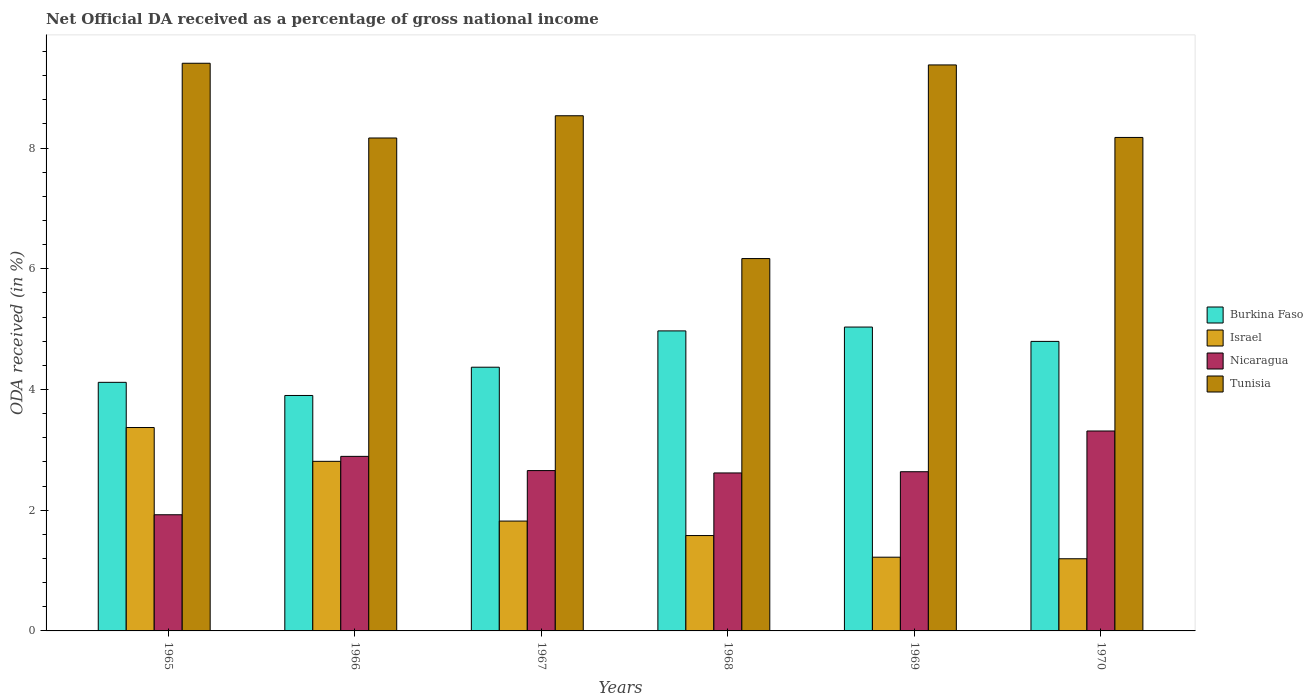How many groups of bars are there?
Your answer should be compact. 6. Are the number of bars on each tick of the X-axis equal?
Ensure brevity in your answer.  Yes. How many bars are there on the 2nd tick from the right?
Make the answer very short. 4. What is the label of the 3rd group of bars from the left?
Offer a very short reply. 1967. In how many cases, is the number of bars for a given year not equal to the number of legend labels?
Your response must be concise. 0. What is the net official DA received in Tunisia in 1970?
Provide a succinct answer. 8.18. Across all years, what is the maximum net official DA received in Burkina Faso?
Provide a succinct answer. 5.03. Across all years, what is the minimum net official DA received in Nicaragua?
Offer a terse response. 1.92. In which year was the net official DA received in Nicaragua minimum?
Provide a short and direct response. 1965. What is the total net official DA received in Nicaragua in the graph?
Offer a very short reply. 16.04. What is the difference between the net official DA received in Nicaragua in 1967 and that in 1969?
Offer a terse response. 0.02. What is the difference between the net official DA received in Burkina Faso in 1968 and the net official DA received in Israel in 1967?
Give a very brief answer. 3.15. What is the average net official DA received in Burkina Faso per year?
Offer a terse response. 4.53. In the year 1970, what is the difference between the net official DA received in Tunisia and net official DA received in Nicaragua?
Offer a very short reply. 4.86. What is the ratio of the net official DA received in Tunisia in 1965 to that in 1967?
Provide a succinct answer. 1.1. Is the net official DA received in Nicaragua in 1966 less than that in 1969?
Make the answer very short. No. What is the difference between the highest and the second highest net official DA received in Nicaragua?
Ensure brevity in your answer.  0.42. What is the difference between the highest and the lowest net official DA received in Nicaragua?
Keep it short and to the point. 1.39. In how many years, is the net official DA received in Burkina Faso greater than the average net official DA received in Burkina Faso taken over all years?
Your answer should be compact. 3. Is the sum of the net official DA received in Nicaragua in 1966 and 1968 greater than the maximum net official DA received in Israel across all years?
Make the answer very short. Yes. Is it the case that in every year, the sum of the net official DA received in Tunisia and net official DA received in Israel is greater than the sum of net official DA received in Burkina Faso and net official DA received in Nicaragua?
Provide a short and direct response. Yes. What does the 1st bar from the left in 1969 represents?
Your response must be concise. Burkina Faso. What does the 2nd bar from the right in 1965 represents?
Ensure brevity in your answer.  Nicaragua. How many years are there in the graph?
Make the answer very short. 6. What is the difference between two consecutive major ticks on the Y-axis?
Give a very brief answer. 2. Are the values on the major ticks of Y-axis written in scientific E-notation?
Your answer should be very brief. No. Does the graph contain grids?
Make the answer very short. No. Where does the legend appear in the graph?
Your answer should be compact. Center right. How many legend labels are there?
Your answer should be compact. 4. What is the title of the graph?
Provide a succinct answer. Net Official DA received as a percentage of gross national income. What is the label or title of the X-axis?
Make the answer very short. Years. What is the label or title of the Y-axis?
Your answer should be very brief. ODA received (in %). What is the ODA received (in %) of Burkina Faso in 1965?
Your response must be concise. 4.12. What is the ODA received (in %) of Israel in 1965?
Ensure brevity in your answer.  3.37. What is the ODA received (in %) of Nicaragua in 1965?
Provide a succinct answer. 1.92. What is the ODA received (in %) of Tunisia in 1965?
Provide a succinct answer. 9.41. What is the ODA received (in %) in Burkina Faso in 1966?
Keep it short and to the point. 3.9. What is the ODA received (in %) of Israel in 1966?
Make the answer very short. 2.81. What is the ODA received (in %) in Nicaragua in 1966?
Your answer should be compact. 2.89. What is the ODA received (in %) of Tunisia in 1966?
Your answer should be very brief. 8.17. What is the ODA received (in %) of Burkina Faso in 1967?
Provide a short and direct response. 4.37. What is the ODA received (in %) of Israel in 1967?
Provide a succinct answer. 1.82. What is the ODA received (in %) of Nicaragua in 1967?
Provide a short and direct response. 2.66. What is the ODA received (in %) of Tunisia in 1967?
Provide a short and direct response. 8.54. What is the ODA received (in %) of Burkina Faso in 1968?
Your response must be concise. 4.97. What is the ODA received (in %) in Israel in 1968?
Your response must be concise. 1.58. What is the ODA received (in %) of Nicaragua in 1968?
Your response must be concise. 2.62. What is the ODA received (in %) in Tunisia in 1968?
Your answer should be very brief. 6.17. What is the ODA received (in %) of Burkina Faso in 1969?
Keep it short and to the point. 5.03. What is the ODA received (in %) of Israel in 1969?
Ensure brevity in your answer.  1.22. What is the ODA received (in %) in Nicaragua in 1969?
Provide a succinct answer. 2.64. What is the ODA received (in %) in Tunisia in 1969?
Offer a terse response. 9.38. What is the ODA received (in %) of Burkina Faso in 1970?
Your answer should be compact. 4.8. What is the ODA received (in %) in Israel in 1970?
Keep it short and to the point. 1.2. What is the ODA received (in %) of Nicaragua in 1970?
Give a very brief answer. 3.31. What is the ODA received (in %) of Tunisia in 1970?
Your response must be concise. 8.18. Across all years, what is the maximum ODA received (in %) of Burkina Faso?
Provide a succinct answer. 5.03. Across all years, what is the maximum ODA received (in %) in Israel?
Offer a very short reply. 3.37. Across all years, what is the maximum ODA received (in %) in Nicaragua?
Your answer should be very brief. 3.31. Across all years, what is the maximum ODA received (in %) in Tunisia?
Provide a succinct answer. 9.41. Across all years, what is the minimum ODA received (in %) of Burkina Faso?
Your response must be concise. 3.9. Across all years, what is the minimum ODA received (in %) of Israel?
Offer a very short reply. 1.2. Across all years, what is the minimum ODA received (in %) of Nicaragua?
Make the answer very short. 1.92. Across all years, what is the minimum ODA received (in %) of Tunisia?
Your answer should be very brief. 6.17. What is the total ODA received (in %) in Burkina Faso in the graph?
Make the answer very short. 27.19. What is the total ODA received (in %) of Israel in the graph?
Make the answer very short. 12. What is the total ODA received (in %) in Nicaragua in the graph?
Provide a succinct answer. 16.04. What is the total ODA received (in %) in Tunisia in the graph?
Your answer should be compact. 49.83. What is the difference between the ODA received (in %) in Burkina Faso in 1965 and that in 1966?
Keep it short and to the point. 0.22. What is the difference between the ODA received (in %) of Israel in 1965 and that in 1966?
Ensure brevity in your answer.  0.56. What is the difference between the ODA received (in %) in Nicaragua in 1965 and that in 1966?
Keep it short and to the point. -0.97. What is the difference between the ODA received (in %) of Tunisia in 1965 and that in 1966?
Make the answer very short. 1.24. What is the difference between the ODA received (in %) in Burkina Faso in 1965 and that in 1967?
Your answer should be very brief. -0.25. What is the difference between the ODA received (in %) in Israel in 1965 and that in 1967?
Your answer should be compact. 1.55. What is the difference between the ODA received (in %) in Nicaragua in 1965 and that in 1967?
Make the answer very short. -0.73. What is the difference between the ODA received (in %) of Tunisia in 1965 and that in 1967?
Keep it short and to the point. 0.87. What is the difference between the ODA received (in %) in Burkina Faso in 1965 and that in 1968?
Make the answer very short. -0.85. What is the difference between the ODA received (in %) in Israel in 1965 and that in 1968?
Offer a terse response. 1.79. What is the difference between the ODA received (in %) in Nicaragua in 1965 and that in 1968?
Offer a terse response. -0.69. What is the difference between the ODA received (in %) in Tunisia in 1965 and that in 1968?
Keep it short and to the point. 3.24. What is the difference between the ODA received (in %) of Burkina Faso in 1965 and that in 1969?
Offer a very short reply. -0.92. What is the difference between the ODA received (in %) in Israel in 1965 and that in 1969?
Make the answer very short. 2.15. What is the difference between the ODA received (in %) of Nicaragua in 1965 and that in 1969?
Your response must be concise. -0.71. What is the difference between the ODA received (in %) of Tunisia in 1965 and that in 1969?
Your answer should be compact. 0.03. What is the difference between the ODA received (in %) of Burkina Faso in 1965 and that in 1970?
Provide a short and direct response. -0.68. What is the difference between the ODA received (in %) of Israel in 1965 and that in 1970?
Provide a short and direct response. 2.17. What is the difference between the ODA received (in %) in Nicaragua in 1965 and that in 1970?
Keep it short and to the point. -1.39. What is the difference between the ODA received (in %) of Tunisia in 1965 and that in 1970?
Offer a terse response. 1.23. What is the difference between the ODA received (in %) in Burkina Faso in 1966 and that in 1967?
Provide a succinct answer. -0.47. What is the difference between the ODA received (in %) of Israel in 1966 and that in 1967?
Your answer should be very brief. 0.99. What is the difference between the ODA received (in %) in Nicaragua in 1966 and that in 1967?
Provide a short and direct response. 0.24. What is the difference between the ODA received (in %) of Tunisia in 1966 and that in 1967?
Provide a short and direct response. -0.37. What is the difference between the ODA received (in %) in Burkina Faso in 1966 and that in 1968?
Give a very brief answer. -1.07. What is the difference between the ODA received (in %) of Israel in 1966 and that in 1968?
Give a very brief answer. 1.23. What is the difference between the ODA received (in %) in Nicaragua in 1966 and that in 1968?
Your response must be concise. 0.27. What is the difference between the ODA received (in %) of Tunisia in 1966 and that in 1968?
Provide a succinct answer. 2. What is the difference between the ODA received (in %) of Burkina Faso in 1966 and that in 1969?
Provide a succinct answer. -1.13. What is the difference between the ODA received (in %) in Israel in 1966 and that in 1969?
Ensure brevity in your answer.  1.59. What is the difference between the ODA received (in %) in Nicaragua in 1966 and that in 1969?
Ensure brevity in your answer.  0.25. What is the difference between the ODA received (in %) of Tunisia in 1966 and that in 1969?
Offer a terse response. -1.21. What is the difference between the ODA received (in %) of Burkina Faso in 1966 and that in 1970?
Ensure brevity in your answer.  -0.9. What is the difference between the ODA received (in %) of Israel in 1966 and that in 1970?
Offer a very short reply. 1.61. What is the difference between the ODA received (in %) of Nicaragua in 1966 and that in 1970?
Your answer should be compact. -0.42. What is the difference between the ODA received (in %) in Tunisia in 1966 and that in 1970?
Provide a short and direct response. -0.01. What is the difference between the ODA received (in %) of Burkina Faso in 1967 and that in 1968?
Offer a very short reply. -0.6. What is the difference between the ODA received (in %) in Israel in 1967 and that in 1968?
Give a very brief answer. 0.24. What is the difference between the ODA received (in %) in Nicaragua in 1967 and that in 1968?
Ensure brevity in your answer.  0.04. What is the difference between the ODA received (in %) in Tunisia in 1967 and that in 1968?
Provide a short and direct response. 2.37. What is the difference between the ODA received (in %) of Burkina Faso in 1967 and that in 1969?
Your answer should be compact. -0.67. What is the difference between the ODA received (in %) in Israel in 1967 and that in 1969?
Provide a succinct answer. 0.6. What is the difference between the ODA received (in %) of Nicaragua in 1967 and that in 1969?
Your answer should be compact. 0.02. What is the difference between the ODA received (in %) in Tunisia in 1967 and that in 1969?
Give a very brief answer. -0.84. What is the difference between the ODA received (in %) in Burkina Faso in 1967 and that in 1970?
Give a very brief answer. -0.43. What is the difference between the ODA received (in %) of Israel in 1967 and that in 1970?
Make the answer very short. 0.62. What is the difference between the ODA received (in %) of Nicaragua in 1967 and that in 1970?
Ensure brevity in your answer.  -0.66. What is the difference between the ODA received (in %) in Tunisia in 1967 and that in 1970?
Offer a terse response. 0.36. What is the difference between the ODA received (in %) of Burkina Faso in 1968 and that in 1969?
Your answer should be very brief. -0.06. What is the difference between the ODA received (in %) of Israel in 1968 and that in 1969?
Offer a very short reply. 0.36. What is the difference between the ODA received (in %) of Nicaragua in 1968 and that in 1969?
Give a very brief answer. -0.02. What is the difference between the ODA received (in %) in Tunisia in 1968 and that in 1969?
Give a very brief answer. -3.21. What is the difference between the ODA received (in %) of Burkina Faso in 1968 and that in 1970?
Offer a terse response. 0.17. What is the difference between the ODA received (in %) in Israel in 1968 and that in 1970?
Your response must be concise. 0.38. What is the difference between the ODA received (in %) in Nicaragua in 1968 and that in 1970?
Give a very brief answer. -0.69. What is the difference between the ODA received (in %) of Tunisia in 1968 and that in 1970?
Provide a succinct answer. -2.01. What is the difference between the ODA received (in %) of Burkina Faso in 1969 and that in 1970?
Provide a succinct answer. 0.24. What is the difference between the ODA received (in %) in Israel in 1969 and that in 1970?
Your answer should be compact. 0.03. What is the difference between the ODA received (in %) in Nicaragua in 1969 and that in 1970?
Your answer should be very brief. -0.67. What is the difference between the ODA received (in %) in Tunisia in 1969 and that in 1970?
Offer a terse response. 1.2. What is the difference between the ODA received (in %) of Burkina Faso in 1965 and the ODA received (in %) of Israel in 1966?
Your answer should be compact. 1.31. What is the difference between the ODA received (in %) of Burkina Faso in 1965 and the ODA received (in %) of Nicaragua in 1966?
Make the answer very short. 1.23. What is the difference between the ODA received (in %) of Burkina Faso in 1965 and the ODA received (in %) of Tunisia in 1966?
Keep it short and to the point. -4.05. What is the difference between the ODA received (in %) of Israel in 1965 and the ODA received (in %) of Nicaragua in 1966?
Offer a terse response. 0.48. What is the difference between the ODA received (in %) of Israel in 1965 and the ODA received (in %) of Tunisia in 1966?
Your answer should be very brief. -4.8. What is the difference between the ODA received (in %) of Nicaragua in 1965 and the ODA received (in %) of Tunisia in 1966?
Provide a short and direct response. -6.24. What is the difference between the ODA received (in %) of Burkina Faso in 1965 and the ODA received (in %) of Israel in 1967?
Provide a short and direct response. 2.3. What is the difference between the ODA received (in %) in Burkina Faso in 1965 and the ODA received (in %) in Nicaragua in 1967?
Your answer should be very brief. 1.46. What is the difference between the ODA received (in %) of Burkina Faso in 1965 and the ODA received (in %) of Tunisia in 1967?
Provide a short and direct response. -4.42. What is the difference between the ODA received (in %) of Israel in 1965 and the ODA received (in %) of Nicaragua in 1967?
Offer a terse response. 0.71. What is the difference between the ODA received (in %) in Israel in 1965 and the ODA received (in %) in Tunisia in 1967?
Give a very brief answer. -5.17. What is the difference between the ODA received (in %) in Nicaragua in 1965 and the ODA received (in %) in Tunisia in 1967?
Offer a terse response. -6.61. What is the difference between the ODA received (in %) in Burkina Faso in 1965 and the ODA received (in %) in Israel in 1968?
Make the answer very short. 2.54. What is the difference between the ODA received (in %) of Burkina Faso in 1965 and the ODA received (in %) of Nicaragua in 1968?
Your answer should be very brief. 1.5. What is the difference between the ODA received (in %) of Burkina Faso in 1965 and the ODA received (in %) of Tunisia in 1968?
Provide a succinct answer. -2.05. What is the difference between the ODA received (in %) of Israel in 1965 and the ODA received (in %) of Nicaragua in 1968?
Give a very brief answer. 0.75. What is the difference between the ODA received (in %) in Israel in 1965 and the ODA received (in %) in Tunisia in 1968?
Give a very brief answer. -2.8. What is the difference between the ODA received (in %) in Nicaragua in 1965 and the ODA received (in %) in Tunisia in 1968?
Provide a short and direct response. -4.24. What is the difference between the ODA received (in %) in Burkina Faso in 1965 and the ODA received (in %) in Israel in 1969?
Ensure brevity in your answer.  2.9. What is the difference between the ODA received (in %) of Burkina Faso in 1965 and the ODA received (in %) of Nicaragua in 1969?
Your answer should be compact. 1.48. What is the difference between the ODA received (in %) in Burkina Faso in 1965 and the ODA received (in %) in Tunisia in 1969?
Keep it short and to the point. -5.26. What is the difference between the ODA received (in %) in Israel in 1965 and the ODA received (in %) in Nicaragua in 1969?
Your response must be concise. 0.73. What is the difference between the ODA received (in %) of Israel in 1965 and the ODA received (in %) of Tunisia in 1969?
Offer a terse response. -6.01. What is the difference between the ODA received (in %) of Nicaragua in 1965 and the ODA received (in %) of Tunisia in 1969?
Offer a terse response. -7.45. What is the difference between the ODA received (in %) of Burkina Faso in 1965 and the ODA received (in %) of Israel in 1970?
Your answer should be very brief. 2.92. What is the difference between the ODA received (in %) in Burkina Faso in 1965 and the ODA received (in %) in Nicaragua in 1970?
Ensure brevity in your answer.  0.81. What is the difference between the ODA received (in %) in Burkina Faso in 1965 and the ODA received (in %) in Tunisia in 1970?
Provide a short and direct response. -4.06. What is the difference between the ODA received (in %) of Israel in 1965 and the ODA received (in %) of Nicaragua in 1970?
Ensure brevity in your answer.  0.06. What is the difference between the ODA received (in %) in Israel in 1965 and the ODA received (in %) in Tunisia in 1970?
Ensure brevity in your answer.  -4.81. What is the difference between the ODA received (in %) in Nicaragua in 1965 and the ODA received (in %) in Tunisia in 1970?
Your answer should be very brief. -6.25. What is the difference between the ODA received (in %) in Burkina Faso in 1966 and the ODA received (in %) in Israel in 1967?
Ensure brevity in your answer.  2.08. What is the difference between the ODA received (in %) in Burkina Faso in 1966 and the ODA received (in %) in Nicaragua in 1967?
Ensure brevity in your answer.  1.24. What is the difference between the ODA received (in %) in Burkina Faso in 1966 and the ODA received (in %) in Tunisia in 1967?
Make the answer very short. -4.63. What is the difference between the ODA received (in %) of Israel in 1966 and the ODA received (in %) of Nicaragua in 1967?
Provide a short and direct response. 0.15. What is the difference between the ODA received (in %) in Israel in 1966 and the ODA received (in %) in Tunisia in 1967?
Offer a terse response. -5.73. What is the difference between the ODA received (in %) of Nicaragua in 1966 and the ODA received (in %) of Tunisia in 1967?
Your answer should be very brief. -5.64. What is the difference between the ODA received (in %) in Burkina Faso in 1966 and the ODA received (in %) in Israel in 1968?
Provide a short and direct response. 2.32. What is the difference between the ODA received (in %) of Burkina Faso in 1966 and the ODA received (in %) of Nicaragua in 1968?
Keep it short and to the point. 1.28. What is the difference between the ODA received (in %) in Burkina Faso in 1966 and the ODA received (in %) in Tunisia in 1968?
Your answer should be very brief. -2.27. What is the difference between the ODA received (in %) in Israel in 1966 and the ODA received (in %) in Nicaragua in 1968?
Offer a very short reply. 0.19. What is the difference between the ODA received (in %) of Israel in 1966 and the ODA received (in %) of Tunisia in 1968?
Your response must be concise. -3.36. What is the difference between the ODA received (in %) of Nicaragua in 1966 and the ODA received (in %) of Tunisia in 1968?
Provide a succinct answer. -3.28. What is the difference between the ODA received (in %) of Burkina Faso in 1966 and the ODA received (in %) of Israel in 1969?
Your answer should be compact. 2.68. What is the difference between the ODA received (in %) in Burkina Faso in 1966 and the ODA received (in %) in Nicaragua in 1969?
Ensure brevity in your answer.  1.26. What is the difference between the ODA received (in %) in Burkina Faso in 1966 and the ODA received (in %) in Tunisia in 1969?
Make the answer very short. -5.48. What is the difference between the ODA received (in %) of Israel in 1966 and the ODA received (in %) of Nicaragua in 1969?
Offer a terse response. 0.17. What is the difference between the ODA received (in %) in Israel in 1966 and the ODA received (in %) in Tunisia in 1969?
Keep it short and to the point. -6.57. What is the difference between the ODA received (in %) in Nicaragua in 1966 and the ODA received (in %) in Tunisia in 1969?
Provide a succinct answer. -6.49. What is the difference between the ODA received (in %) in Burkina Faso in 1966 and the ODA received (in %) in Israel in 1970?
Provide a succinct answer. 2.71. What is the difference between the ODA received (in %) in Burkina Faso in 1966 and the ODA received (in %) in Nicaragua in 1970?
Your answer should be compact. 0.59. What is the difference between the ODA received (in %) of Burkina Faso in 1966 and the ODA received (in %) of Tunisia in 1970?
Your response must be concise. -4.28. What is the difference between the ODA received (in %) in Israel in 1966 and the ODA received (in %) in Nicaragua in 1970?
Your response must be concise. -0.5. What is the difference between the ODA received (in %) of Israel in 1966 and the ODA received (in %) of Tunisia in 1970?
Offer a very short reply. -5.37. What is the difference between the ODA received (in %) of Nicaragua in 1966 and the ODA received (in %) of Tunisia in 1970?
Provide a succinct answer. -5.28. What is the difference between the ODA received (in %) in Burkina Faso in 1967 and the ODA received (in %) in Israel in 1968?
Provide a short and direct response. 2.79. What is the difference between the ODA received (in %) of Burkina Faso in 1967 and the ODA received (in %) of Nicaragua in 1968?
Keep it short and to the point. 1.75. What is the difference between the ODA received (in %) of Burkina Faso in 1967 and the ODA received (in %) of Tunisia in 1968?
Offer a very short reply. -1.8. What is the difference between the ODA received (in %) of Israel in 1967 and the ODA received (in %) of Nicaragua in 1968?
Give a very brief answer. -0.8. What is the difference between the ODA received (in %) of Israel in 1967 and the ODA received (in %) of Tunisia in 1968?
Offer a very short reply. -4.35. What is the difference between the ODA received (in %) of Nicaragua in 1967 and the ODA received (in %) of Tunisia in 1968?
Give a very brief answer. -3.51. What is the difference between the ODA received (in %) of Burkina Faso in 1967 and the ODA received (in %) of Israel in 1969?
Ensure brevity in your answer.  3.15. What is the difference between the ODA received (in %) of Burkina Faso in 1967 and the ODA received (in %) of Nicaragua in 1969?
Offer a very short reply. 1.73. What is the difference between the ODA received (in %) in Burkina Faso in 1967 and the ODA received (in %) in Tunisia in 1969?
Provide a succinct answer. -5.01. What is the difference between the ODA received (in %) in Israel in 1967 and the ODA received (in %) in Nicaragua in 1969?
Make the answer very short. -0.82. What is the difference between the ODA received (in %) in Israel in 1967 and the ODA received (in %) in Tunisia in 1969?
Offer a terse response. -7.56. What is the difference between the ODA received (in %) of Nicaragua in 1967 and the ODA received (in %) of Tunisia in 1969?
Ensure brevity in your answer.  -6.72. What is the difference between the ODA received (in %) in Burkina Faso in 1967 and the ODA received (in %) in Israel in 1970?
Your answer should be very brief. 3.17. What is the difference between the ODA received (in %) of Burkina Faso in 1967 and the ODA received (in %) of Nicaragua in 1970?
Make the answer very short. 1.06. What is the difference between the ODA received (in %) of Burkina Faso in 1967 and the ODA received (in %) of Tunisia in 1970?
Give a very brief answer. -3.81. What is the difference between the ODA received (in %) in Israel in 1967 and the ODA received (in %) in Nicaragua in 1970?
Provide a short and direct response. -1.49. What is the difference between the ODA received (in %) in Israel in 1967 and the ODA received (in %) in Tunisia in 1970?
Your answer should be compact. -6.36. What is the difference between the ODA received (in %) in Nicaragua in 1967 and the ODA received (in %) in Tunisia in 1970?
Ensure brevity in your answer.  -5.52. What is the difference between the ODA received (in %) in Burkina Faso in 1968 and the ODA received (in %) in Israel in 1969?
Make the answer very short. 3.75. What is the difference between the ODA received (in %) in Burkina Faso in 1968 and the ODA received (in %) in Nicaragua in 1969?
Your answer should be very brief. 2.33. What is the difference between the ODA received (in %) in Burkina Faso in 1968 and the ODA received (in %) in Tunisia in 1969?
Your response must be concise. -4.41. What is the difference between the ODA received (in %) in Israel in 1968 and the ODA received (in %) in Nicaragua in 1969?
Keep it short and to the point. -1.06. What is the difference between the ODA received (in %) in Israel in 1968 and the ODA received (in %) in Tunisia in 1969?
Keep it short and to the point. -7.8. What is the difference between the ODA received (in %) of Nicaragua in 1968 and the ODA received (in %) of Tunisia in 1969?
Provide a short and direct response. -6.76. What is the difference between the ODA received (in %) of Burkina Faso in 1968 and the ODA received (in %) of Israel in 1970?
Give a very brief answer. 3.78. What is the difference between the ODA received (in %) of Burkina Faso in 1968 and the ODA received (in %) of Nicaragua in 1970?
Make the answer very short. 1.66. What is the difference between the ODA received (in %) of Burkina Faso in 1968 and the ODA received (in %) of Tunisia in 1970?
Your answer should be compact. -3.21. What is the difference between the ODA received (in %) in Israel in 1968 and the ODA received (in %) in Nicaragua in 1970?
Your answer should be compact. -1.73. What is the difference between the ODA received (in %) in Israel in 1968 and the ODA received (in %) in Tunisia in 1970?
Your answer should be very brief. -6.6. What is the difference between the ODA received (in %) in Nicaragua in 1968 and the ODA received (in %) in Tunisia in 1970?
Offer a terse response. -5.56. What is the difference between the ODA received (in %) of Burkina Faso in 1969 and the ODA received (in %) of Israel in 1970?
Your response must be concise. 3.84. What is the difference between the ODA received (in %) in Burkina Faso in 1969 and the ODA received (in %) in Nicaragua in 1970?
Provide a short and direct response. 1.72. What is the difference between the ODA received (in %) in Burkina Faso in 1969 and the ODA received (in %) in Tunisia in 1970?
Your answer should be very brief. -3.14. What is the difference between the ODA received (in %) of Israel in 1969 and the ODA received (in %) of Nicaragua in 1970?
Give a very brief answer. -2.09. What is the difference between the ODA received (in %) in Israel in 1969 and the ODA received (in %) in Tunisia in 1970?
Your answer should be very brief. -6.95. What is the difference between the ODA received (in %) of Nicaragua in 1969 and the ODA received (in %) of Tunisia in 1970?
Ensure brevity in your answer.  -5.54. What is the average ODA received (in %) in Burkina Faso per year?
Ensure brevity in your answer.  4.53. What is the average ODA received (in %) in Israel per year?
Ensure brevity in your answer.  2. What is the average ODA received (in %) in Nicaragua per year?
Keep it short and to the point. 2.67. What is the average ODA received (in %) of Tunisia per year?
Your response must be concise. 8.31. In the year 1965, what is the difference between the ODA received (in %) of Burkina Faso and ODA received (in %) of Israel?
Ensure brevity in your answer.  0.75. In the year 1965, what is the difference between the ODA received (in %) of Burkina Faso and ODA received (in %) of Nicaragua?
Make the answer very short. 2.19. In the year 1965, what is the difference between the ODA received (in %) of Burkina Faso and ODA received (in %) of Tunisia?
Offer a very short reply. -5.29. In the year 1965, what is the difference between the ODA received (in %) in Israel and ODA received (in %) in Nicaragua?
Make the answer very short. 1.45. In the year 1965, what is the difference between the ODA received (in %) in Israel and ODA received (in %) in Tunisia?
Give a very brief answer. -6.04. In the year 1965, what is the difference between the ODA received (in %) of Nicaragua and ODA received (in %) of Tunisia?
Offer a terse response. -7.48. In the year 1966, what is the difference between the ODA received (in %) in Burkina Faso and ODA received (in %) in Israel?
Your answer should be compact. 1.09. In the year 1966, what is the difference between the ODA received (in %) in Burkina Faso and ODA received (in %) in Nicaragua?
Your answer should be very brief. 1.01. In the year 1966, what is the difference between the ODA received (in %) in Burkina Faso and ODA received (in %) in Tunisia?
Your response must be concise. -4.27. In the year 1966, what is the difference between the ODA received (in %) of Israel and ODA received (in %) of Nicaragua?
Make the answer very short. -0.08. In the year 1966, what is the difference between the ODA received (in %) of Israel and ODA received (in %) of Tunisia?
Your answer should be very brief. -5.36. In the year 1966, what is the difference between the ODA received (in %) of Nicaragua and ODA received (in %) of Tunisia?
Offer a very short reply. -5.28. In the year 1967, what is the difference between the ODA received (in %) of Burkina Faso and ODA received (in %) of Israel?
Your response must be concise. 2.55. In the year 1967, what is the difference between the ODA received (in %) of Burkina Faso and ODA received (in %) of Nicaragua?
Keep it short and to the point. 1.71. In the year 1967, what is the difference between the ODA received (in %) in Burkina Faso and ODA received (in %) in Tunisia?
Provide a short and direct response. -4.17. In the year 1967, what is the difference between the ODA received (in %) of Israel and ODA received (in %) of Nicaragua?
Provide a short and direct response. -0.84. In the year 1967, what is the difference between the ODA received (in %) in Israel and ODA received (in %) in Tunisia?
Provide a short and direct response. -6.72. In the year 1967, what is the difference between the ODA received (in %) of Nicaragua and ODA received (in %) of Tunisia?
Provide a short and direct response. -5.88. In the year 1968, what is the difference between the ODA received (in %) of Burkina Faso and ODA received (in %) of Israel?
Ensure brevity in your answer.  3.39. In the year 1968, what is the difference between the ODA received (in %) of Burkina Faso and ODA received (in %) of Nicaragua?
Ensure brevity in your answer.  2.35. In the year 1968, what is the difference between the ODA received (in %) of Burkina Faso and ODA received (in %) of Tunisia?
Your response must be concise. -1.2. In the year 1968, what is the difference between the ODA received (in %) in Israel and ODA received (in %) in Nicaragua?
Your answer should be very brief. -1.04. In the year 1968, what is the difference between the ODA received (in %) of Israel and ODA received (in %) of Tunisia?
Your answer should be compact. -4.59. In the year 1968, what is the difference between the ODA received (in %) in Nicaragua and ODA received (in %) in Tunisia?
Provide a short and direct response. -3.55. In the year 1969, what is the difference between the ODA received (in %) of Burkina Faso and ODA received (in %) of Israel?
Keep it short and to the point. 3.81. In the year 1969, what is the difference between the ODA received (in %) of Burkina Faso and ODA received (in %) of Nicaragua?
Give a very brief answer. 2.4. In the year 1969, what is the difference between the ODA received (in %) of Burkina Faso and ODA received (in %) of Tunisia?
Offer a terse response. -4.34. In the year 1969, what is the difference between the ODA received (in %) in Israel and ODA received (in %) in Nicaragua?
Your answer should be compact. -1.42. In the year 1969, what is the difference between the ODA received (in %) of Israel and ODA received (in %) of Tunisia?
Offer a very short reply. -8.16. In the year 1969, what is the difference between the ODA received (in %) in Nicaragua and ODA received (in %) in Tunisia?
Make the answer very short. -6.74. In the year 1970, what is the difference between the ODA received (in %) of Burkina Faso and ODA received (in %) of Israel?
Offer a very short reply. 3.6. In the year 1970, what is the difference between the ODA received (in %) in Burkina Faso and ODA received (in %) in Nicaragua?
Your answer should be very brief. 1.48. In the year 1970, what is the difference between the ODA received (in %) of Burkina Faso and ODA received (in %) of Tunisia?
Make the answer very short. -3.38. In the year 1970, what is the difference between the ODA received (in %) in Israel and ODA received (in %) in Nicaragua?
Give a very brief answer. -2.12. In the year 1970, what is the difference between the ODA received (in %) in Israel and ODA received (in %) in Tunisia?
Keep it short and to the point. -6.98. In the year 1970, what is the difference between the ODA received (in %) of Nicaragua and ODA received (in %) of Tunisia?
Your answer should be compact. -4.86. What is the ratio of the ODA received (in %) in Burkina Faso in 1965 to that in 1966?
Provide a succinct answer. 1.06. What is the ratio of the ODA received (in %) of Israel in 1965 to that in 1966?
Your answer should be compact. 1.2. What is the ratio of the ODA received (in %) of Nicaragua in 1965 to that in 1966?
Offer a very short reply. 0.67. What is the ratio of the ODA received (in %) of Tunisia in 1965 to that in 1966?
Your response must be concise. 1.15. What is the ratio of the ODA received (in %) in Burkina Faso in 1965 to that in 1967?
Make the answer very short. 0.94. What is the ratio of the ODA received (in %) in Israel in 1965 to that in 1967?
Offer a very short reply. 1.85. What is the ratio of the ODA received (in %) of Nicaragua in 1965 to that in 1967?
Offer a very short reply. 0.72. What is the ratio of the ODA received (in %) of Tunisia in 1965 to that in 1967?
Provide a short and direct response. 1.1. What is the ratio of the ODA received (in %) in Burkina Faso in 1965 to that in 1968?
Offer a very short reply. 0.83. What is the ratio of the ODA received (in %) of Israel in 1965 to that in 1968?
Offer a very short reply. 2.13. What is the ratio of the ODA received (in %) in Nicaragua in 1965 to that in 1968?
Ensure brevity in your answer.  0.74. What is the ratio of the ODA received (in %) of Tunisia in 1965 to that in 1968?
Offer a terse response. 1.52. What is the ratio of the ODA received (in %) in Burkina Faso in 1965 to that in 1969?
Give a very brief answer. 0.82. What is the ratio of the ODA received (in %) in Israel in 1965 to that in 1969?
Keep it short and to the point. 2.76. What is the ratio of the ODA received (in %) in Nicaragua in 1965 to that in 1969?
Ensure brevity in your answer.  0.73. What is the ratio of the ODA received (in %) of Tunisia in 1965 to that in 1969?
Your answer should be very brief. 1. What is the ratio of the ODA received (in %) of Burkina Faso in 1965 to that in 1970?
Your response must be concise. 0.86. What is the ratio of the ODA received (in %) in Israel in 1965 to that in 1970?
Make the answer very short. 2.82. What is the ratio of the ODA received (in %) in Nicaragua in 1965 to that in 1970?
Give a very brief answer. 0.58. What is the ratio of the ODA received (in %) of Tunisia in 1965 to that in 1970?
Your answer should be very brief. 1.15. What is the ratio of the ODA received (in %) of Burkina Faso in 1966 to that in 1967?
Make the answer very short. 0.89. What is the ratio of the ODA received (in %) in Israel in 1966 to that in 1967?
Your answer should be very brief. 1.54. What is the ratio of the ODA received (in %) in Nicaragua in 1966 to that in 1967?
Keep it short and to the point. 1.09. What is the ratio of the ODA received (in %) in Tunisia in 1966 to that in 1967?
Ensure brevity in your answer.  0.96. What is the ratio of the ODA received (in %) of Burkina Faso in 1966 to that in 1968?
Make the answer very short. 0.78. What is the ratio of the ODA received (in %) of Israel in 1966 to that in 1968?
Ensure brevity in your answer.  1.78. What is the ratio of the ODA received (in %) in Nicaragua in 1966 to that in 1968?
Ensure brevity in your answer.  1.1. What is the ratio of the ODA received (in %) in Tunisia in 1966 to that in 1968?
Make the answer very short. 1.32. What is the ratio of the ODA received (in %) in Burkina Faso in 1966 to that in 1969?
Your answer should be compact. 0.77. What is the ratio of the ODA received (in %) in Israel in 1966 to that in 1969?
Ensure brevity in your answer.  2.3. What is the ratio of the ODA received (in %) of Nicaragua in 1966 to that in 1969?
Give a very brief answer. 1.1. What is the ratio of the ODA received (in %) of Tunisia in 1966 to that in 1969?
Your answer should be compact. 0.87. What is the ratio of the ODA received (in %) of Burkina Faso in 1966 to that in 1970?
Provide a short and direct response. 0.81. What is the ratio of the ODA received (in %) in Israel in 1966 to that in 1970?
Your answer should be very brief. 2.35. What is the ratio of the ODA received (in %) of Nicaragua in 1966 to that in 1970?
Your answer should be compact. 0.87. What is the ratio of the ODA received (in %) in Tunisia in 1966 to that in 1970?
Your answer should be compact. 1. What is the ratio of the ODA received (in %) of Burkina Faso in 1967 to that in 1968?
Offer a very short reply. 0.88. What is the ratio of the ODA received (in %) in Israel in 1967 to that in 1968?
Give a very brief answer. 1.15. What is the ratio of the ODA received (in %) in Nicaragua in 1967 to that in 1968?
Your response must be concise. 1.01. What is the ratio of the ODA received (in %) in Tunisia in 1967 to that in 1968?
Ensure brevity in your answer.  1.38. What is the ratio of the ODA received (in %) of Burkina Faso in 1967 to that in 1969?
Make the answer very short. 0.87. What is the ratio of the ODA received (in %) in Israel in 1967 to that in 1969?
Your response must be concise. 1.49. What is the ratio of the ODA received (in %) in Nicaragua in 1967 to that in 1969?
Keep it short and to the point. 1.01. What is the ratio of the ODA received (in %) in Tunisia in 1967 to that in 1969?
Offer a terse response. 0.91. What is the ratio of the ODA received (in %) of Burkina Faso in 1967 to that in 1970?
Offer a terse response. 0.91. What is the ratio of the ODA received (in %) of Israel in 1967 to that in 1970?
Your response must be concise. 1.52. What is the ratio of the ODA received (in %) in Nicaragua in 1967 to that in 1970?
Offer a terse response. 0.8. What is the ratio of the ODA received (in %) in Tunisia in 1967 to that in 1970?
Offer a very short reply. 1.04. What is the ratio of the ODA received (in %) of Burkina Faso in 1968 to that in 1969?
Offer a very short reply. 0.99. What is the ratio of the ODA received (in %) of Israel in 1968 to that in 1969?
Your answer should be compact. 1.29. What is the ratio of the ODA received (in %) in Nicaragua in 1968 to that in 1969?
Provide a short and direct response. 0.99. What is the ratio of the ODA received (in %) of Tunisia in 1968 to that in 1969?
Give a very brief answer. 0.66. What is the ratio of the ODA received (in %) of Burkina Faso in 1968 to that in 1970?
Offer a terse response. 1.04. What is the ratio of the ODA received (in %) of Israel in 1968 to that in 1970?
Make the answer very short. 1.32. What is the ratio of the ODA received (in %) in Nicaragua in 1968 to that in 1970?
Keep it short and to the point. 0.79. What is the ratio of the ODA received (in %) in Tunisia in 1968 to that in 1970?
Make the answer very short. 0.75. What is the ratio of the ODA received (in %) of Burkina Faso in 1969 to that in 1970?
Provide a succinct answer. 1.05. What is the ratio of the ODA received (in %) in Israel in 1969 to that in 1970?
Your response must be concise. 1.02. What is the ratio of the ODA received (in %) of Nicaragua in 1969 to that in 1970?
Offer a very short reply. 0.8. What is the ratio of the ODA received (in %) in Tunisia in 1969 to that in 1970?
Provide a succinct answer. 1.15. What is the difference between the highest and the second highest ODA received (in %) of Burkina Faso?
Your answer should be very brief. 0.06. What is the difference between the highest and the second highest ODA received (in %) of Israel?
Give a very brief answer. 0.56. What is the difference between the highest and the second highest ODA received (in %) in Nicaragua?
Your answer should be very brief. 0.42. What is the difference between the highest and the second highest ODA received (in %) of Tunisia?
Your answer should be compact. 0.03. What is the difference between the highest and the lowest ODA received (in %) in Burkina Faso?
Ensure brevity in your answer.  1.13. What is the difference between the highest and the lowest ODA received (in %) of Israel?
Provide a short and direct response. 2.17. What is the difference between the highest and the lowest ODA received (in %) of Nicaragua?
Your answer should be compact. 1.39. What is the difference between the highest and the lowest ODA received (in %) of Tunisia?
Your response must be concise. 3.24. 